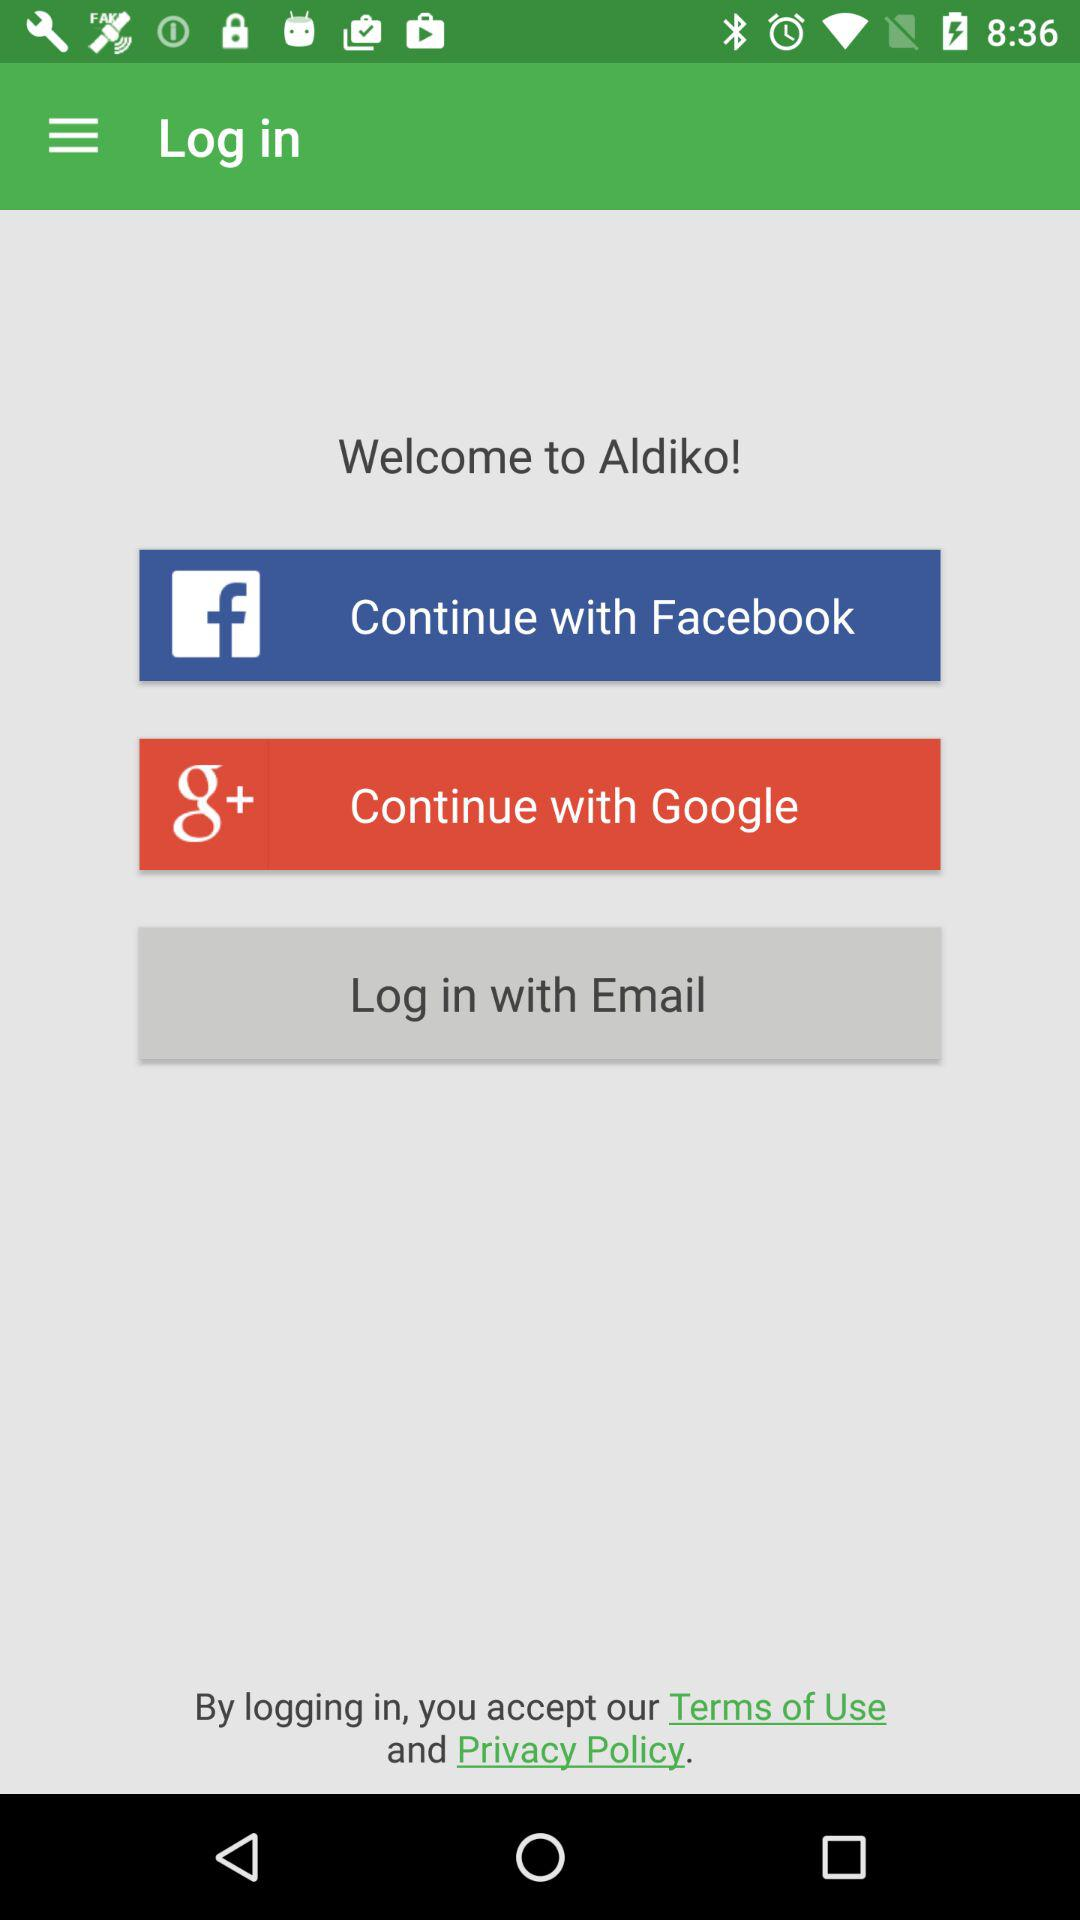Which are the different login options? The different login options are "Facebook", "Email" and "Google". 